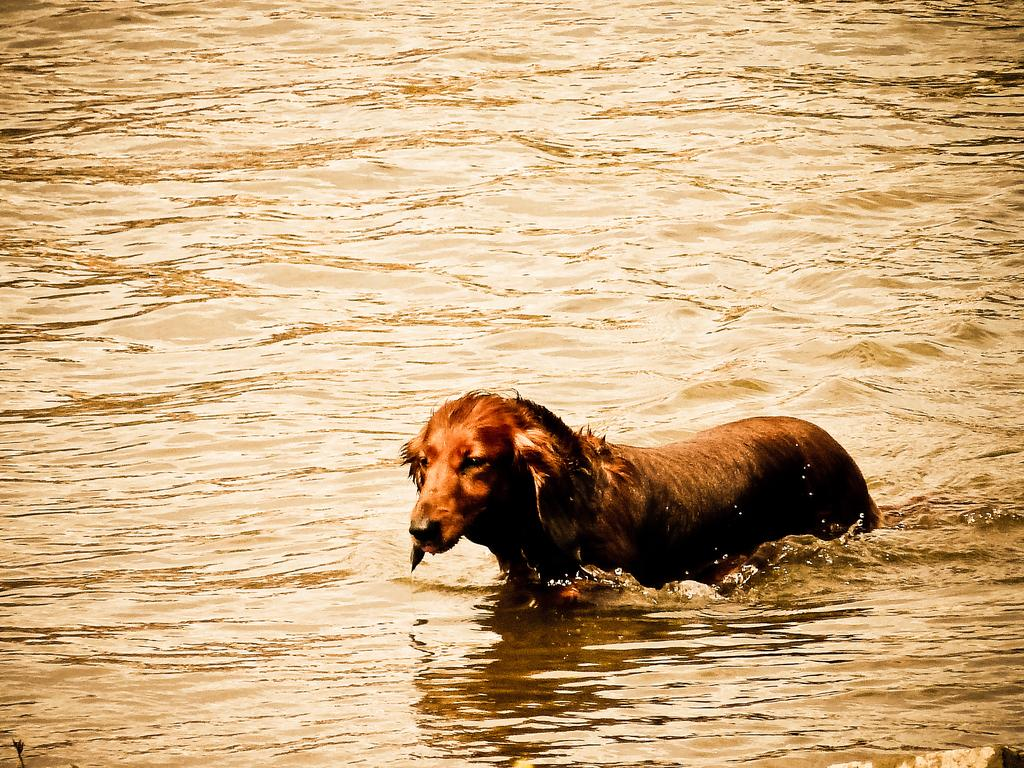What animal can be seen in the image? There is a dog in the image. image. What is the dog doing in the image? The dog is walking in a pond. What type of ink is being used in the hospital in the image? There is no hospital or ink present in the image; it features a dog walking in a pond. What is the cannon firing at in the image? There is no cannon present in the image; it features a dog walking in a pond. 